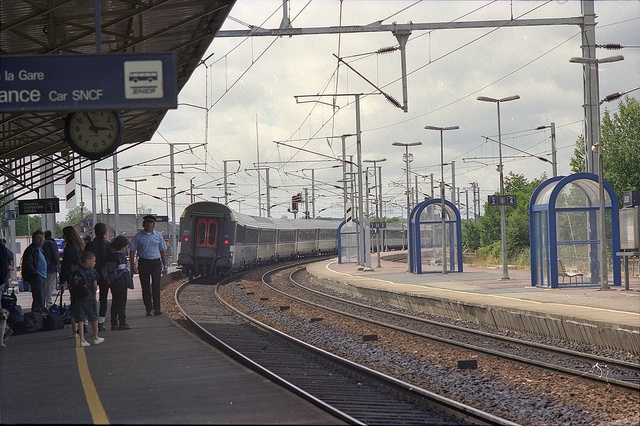Describe the objects in this image and their specific colors. I can see train in black, gray, and darkgray tones, clock in black tones, people in black and gray tones, people in black and gray tones, and people in black and gray tones in this image. 